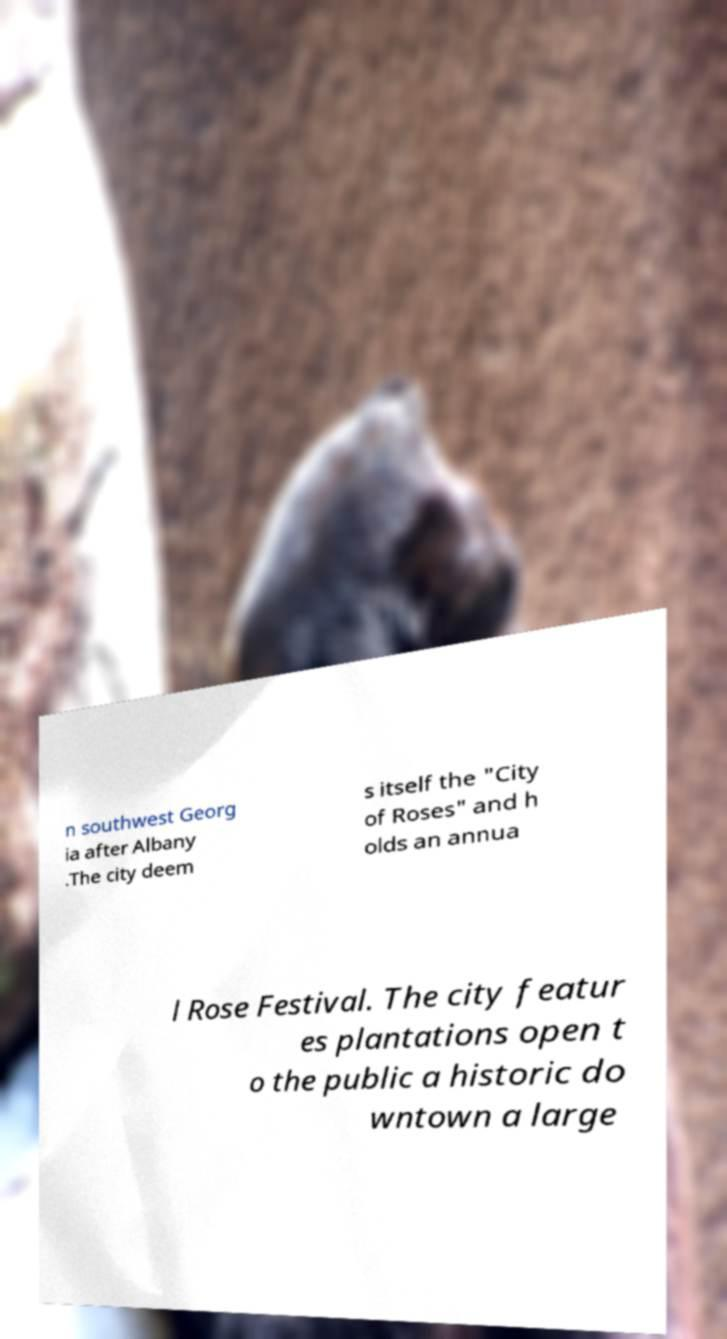I need the written content from this picture converted into text. Can you do that? n southwest Georg ia after Albany .The city deem s itself the "City of Roses" and h olds an annua l Rose Festival. The city featur es plantations open t o the public a historic do wntown a large 